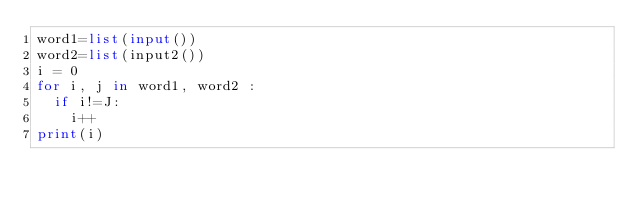Convert code to text. <code><loc_0><loc_0><loc_500><loc_500><_Python_>word1=list(input())
word2=list(input2())
i = 0
for i, j in word1, word2 :
  if i!=J:
    i++
print(i)
    </code> 